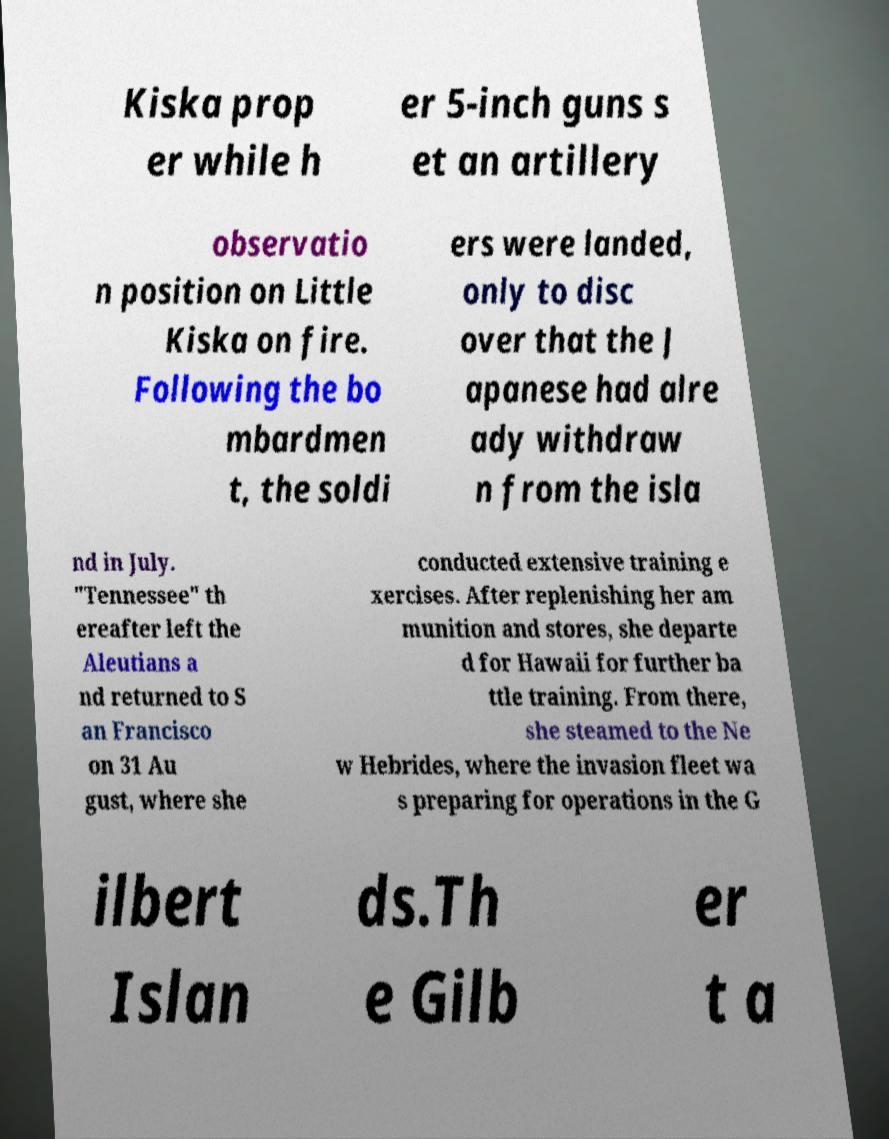For documentation purposes, I need the text within this image transcribed. Could you provide that? Kiska prop er while h er 5-inch guns s et an artillery observatio n position on Little Kiska on fire. Following the bo mbardmen t, the soldi ers were landed, only to disc over that the J apanese had alre ady withdraw n from the isla nd in July. "Tennessee" th ereafter left the Aleutians a nd returned to S an Francisco on 31 Au gust, where she conducted extensive training e xercises. After replenishing her am munition and stores, she departe d for Hawaii for further ba ttle training. From there, she steamed to the Ne w Hebrides, where the invasion fleet wa s preparing for operations in the G ilbert Islan ds.Th e Gilb er t a 